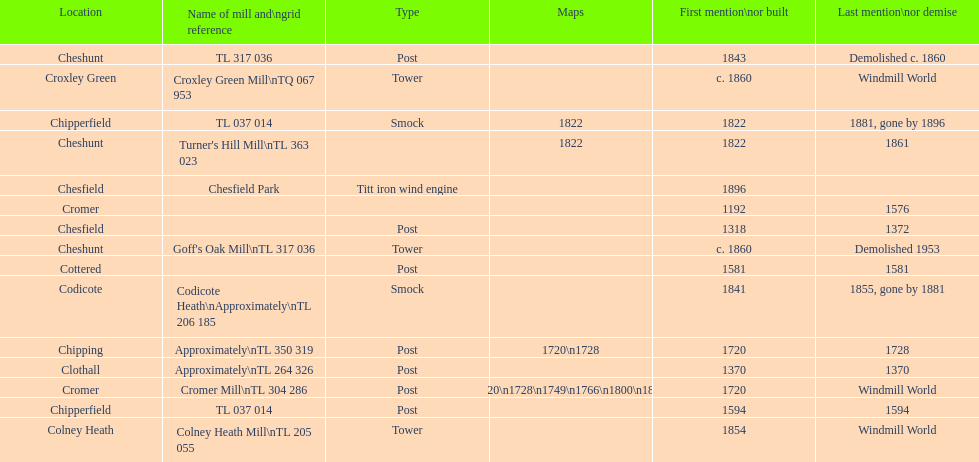Could you parse the entire table? {'header': ['Location', 'Name of mill and\\ngrid reference', 'Type', 'Maps', 'First mention\\nor built', 'Last mention\\nor demise'], 'rows': [['Cheshunt', 'TL 317 036', 'Post', '', '1843', 'Demolished c. 1860'], ['Croxley Green', 'Croxley Green Mill\\nTQ 067 953', 'Tower', '', 'c. 1860', 'Windmill World'], ['Chipperfield', 'TL 037 014', 'Smock', '1822', '1822', '1881, gone by 1896'], ['Cheshunt', "Turner's Hill Mill\\nTL 363 023", '', '1822', '1822', '1861'], ['Chesfield', 'Chesfield Park', 'Titt iron wind engine', '', '1896', ''], ['Cromer', '', '', '', '1192', '1576'], ['Chesfield', '', 'Post', '', '1318', '1372'], ['Cheshunt', "Goff's Oak Mill\\nTL 317 036", 'Tower', '', 'c. 1860', 'Demolished 1953'], ['Cottered', '', 'Post', '', '1581', '1581'], ['Codicote', 'Codicote Heath\\nApproximately\\nTL 206 185', 'Smock', '', '1841', '1855, gone by 1881'], ['Chipping', 'Approximately\\nTL 350 319', 'Post', '1720\\n1728', '1720', '1728'], ['Clothall', 'Approximately\\nTL 264 326', 'Post', '', '1370', '1370'], ['Cromer', 'Cromer Mill\\nTL 304 286', 'Post', '1720\\n1728\\n1749\\n1766\\n1800\\n1822', '1720', 'Windmill World'], ['Chipperfield', 'TL 037 014', 'Post', '', '1594', '1594'], ['Colney Heath', 'Colney Heath Mill\\nTL 205 055', 'Tower', '', '1854', 'Windmill World']]} Did cromer, chipperfield or cheshunt have the most windmills? Cheshunt. 